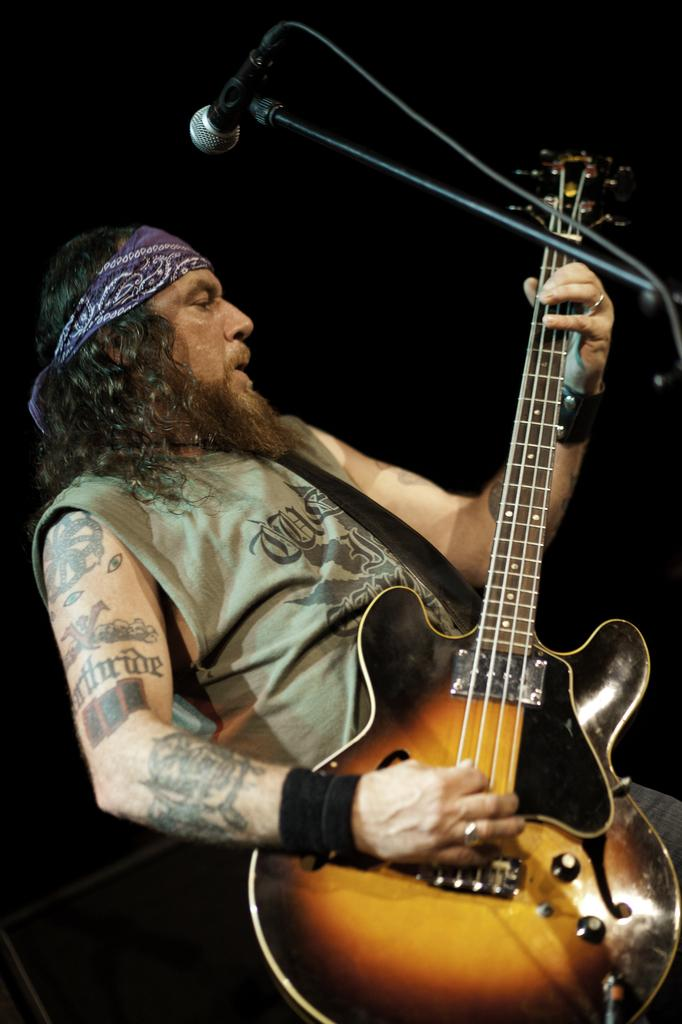What is the main subject of the image? There is a person in the image. What is the person wearing? The person is wearing clothes. What activity is the person engaged in? The person is playing a guitar. What object is in front of the person? The person is standing in front of a microphone. What type of haircut does the person have in the image? The provided facts do not mention the person's haircut, so it cannot be determined from the image. What color is the chalk used by the person in the image? There is no chalk present in the image; the person is playing a guitar and standing in front of a microphone. 